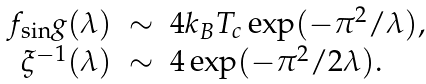Convert formula to latex. <formula><loc_0><loc_0><loc_500><loc_500>\begin{array} { r c l } f _ { \sin } g ( \lambda ) & \sim & 4 k _ { B } T _ { c } \exp ( - \pi ^ { 2 } / \lambda ) , \\ \xi ^ { - 1 } ( \lambda ) & \sim & 4 \exp ( - \pi ^ { 2 } / 2 \lambda ) . \end{array}</formula> 